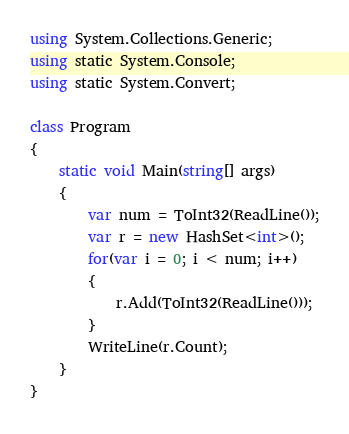<code> <loc_0><loc_0><loc_500><loc_500><_C#_>using System.Collections.Generic;
using static System.Console;
using static System.Convert;

class Program
{
    static void Main(string[] args)
    {
        var num = ToInt32(ReadLine());
        var r = new HashSet<int>();
        for(var i = 0; i < num; i++)
        {
            r.Add(ToInt32(ReadLine()));
        }
        WriteLine(r.Count);
    }
}</code> 